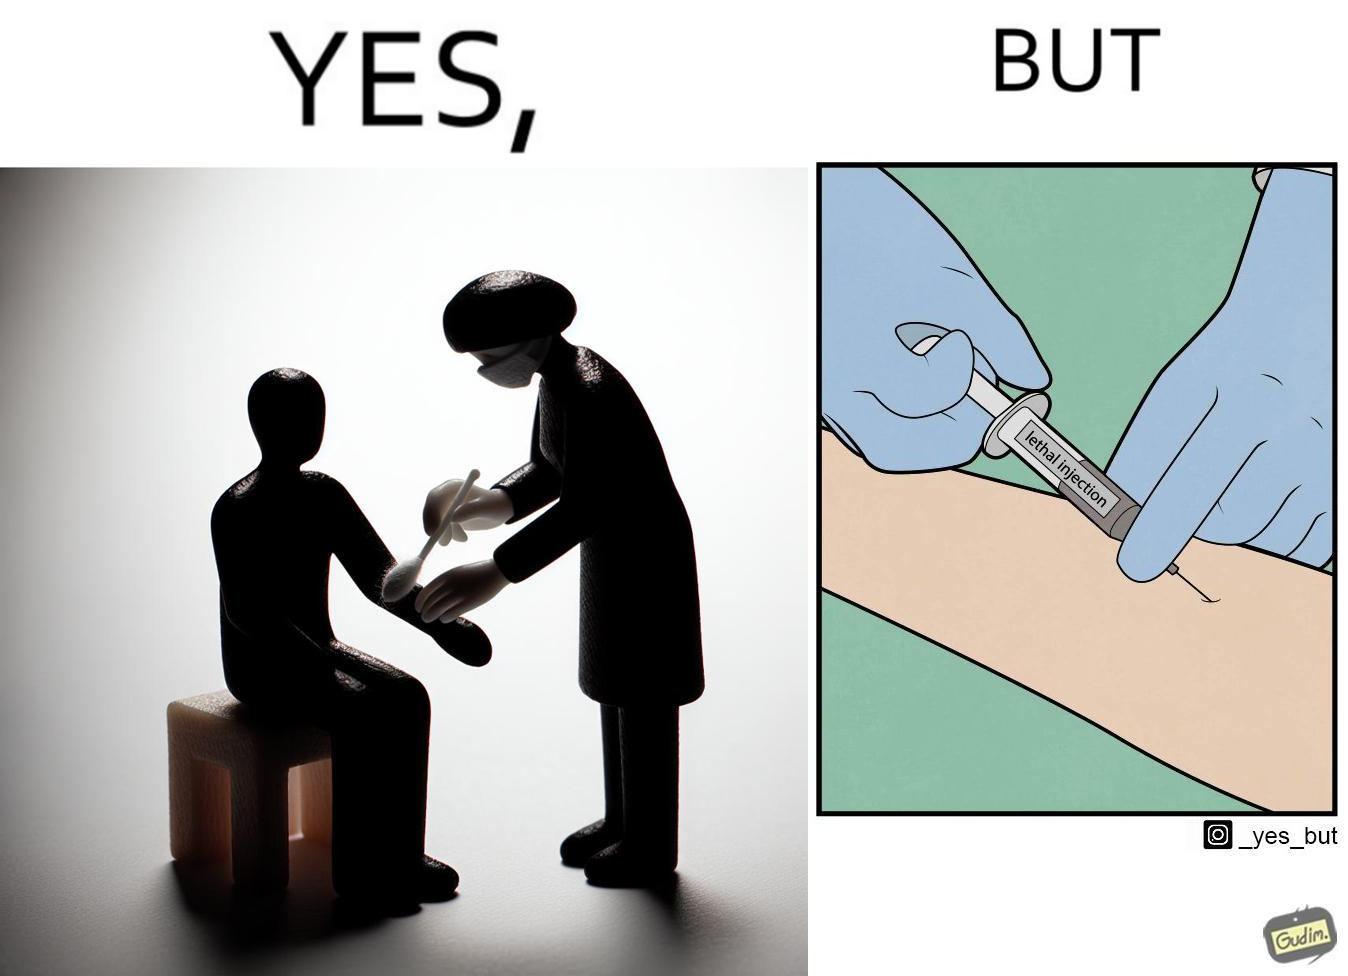What is the satirical meaning behind this image? The image is ironical, as rubbing alcohol is used to clean a place on the arm for giving an injection, while the injection itself is 'lethal'. 